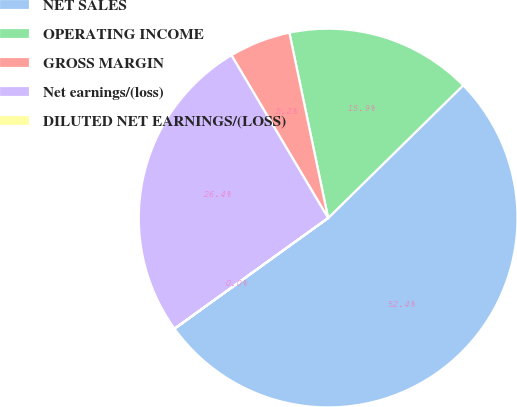Convert chart. <chart><loc_0><loc_0><loc_500><loc_500><pie_chart><fcel>NET SALES<fcel>OPERATING INCOME<fcel>GROSS MARGIN<fcel>Net earnings/(loss)<fcel>DILUTED NET EARNINGS/(LOSS)<nl><fcel>52.42%<fcel>15.92%<fcel>5.25%<fcel>26.4%<fcel>0.01%<nl></chart> 